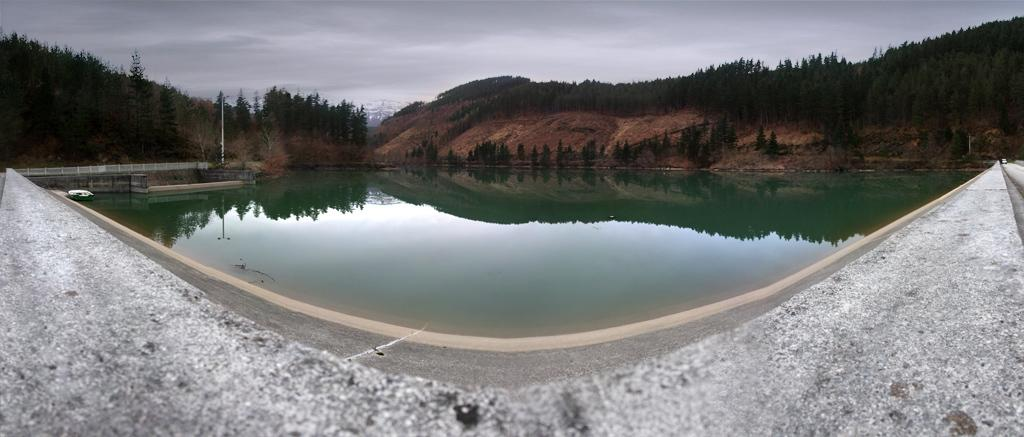What can be seen on the wall in the image? The surface of the wall is visible in the image. What natural element is present in the image? Water is visible in the image. What type of landscape feature can be seen in the image? Hills are present in the image. What object is standing upright in the image? There is a pole in the image. What type of vegetation is visible in the image? Trees are visible in the image. What is the condition of the sky in the background of the image? The sky in the background is cloudy. What type of quartz can be seen on the pole in the image? There is no quartz present in the image, and the pole does not have any quartz on it. How does the skate move around in the image? There is no skate present in the image, so it cannot move around. 